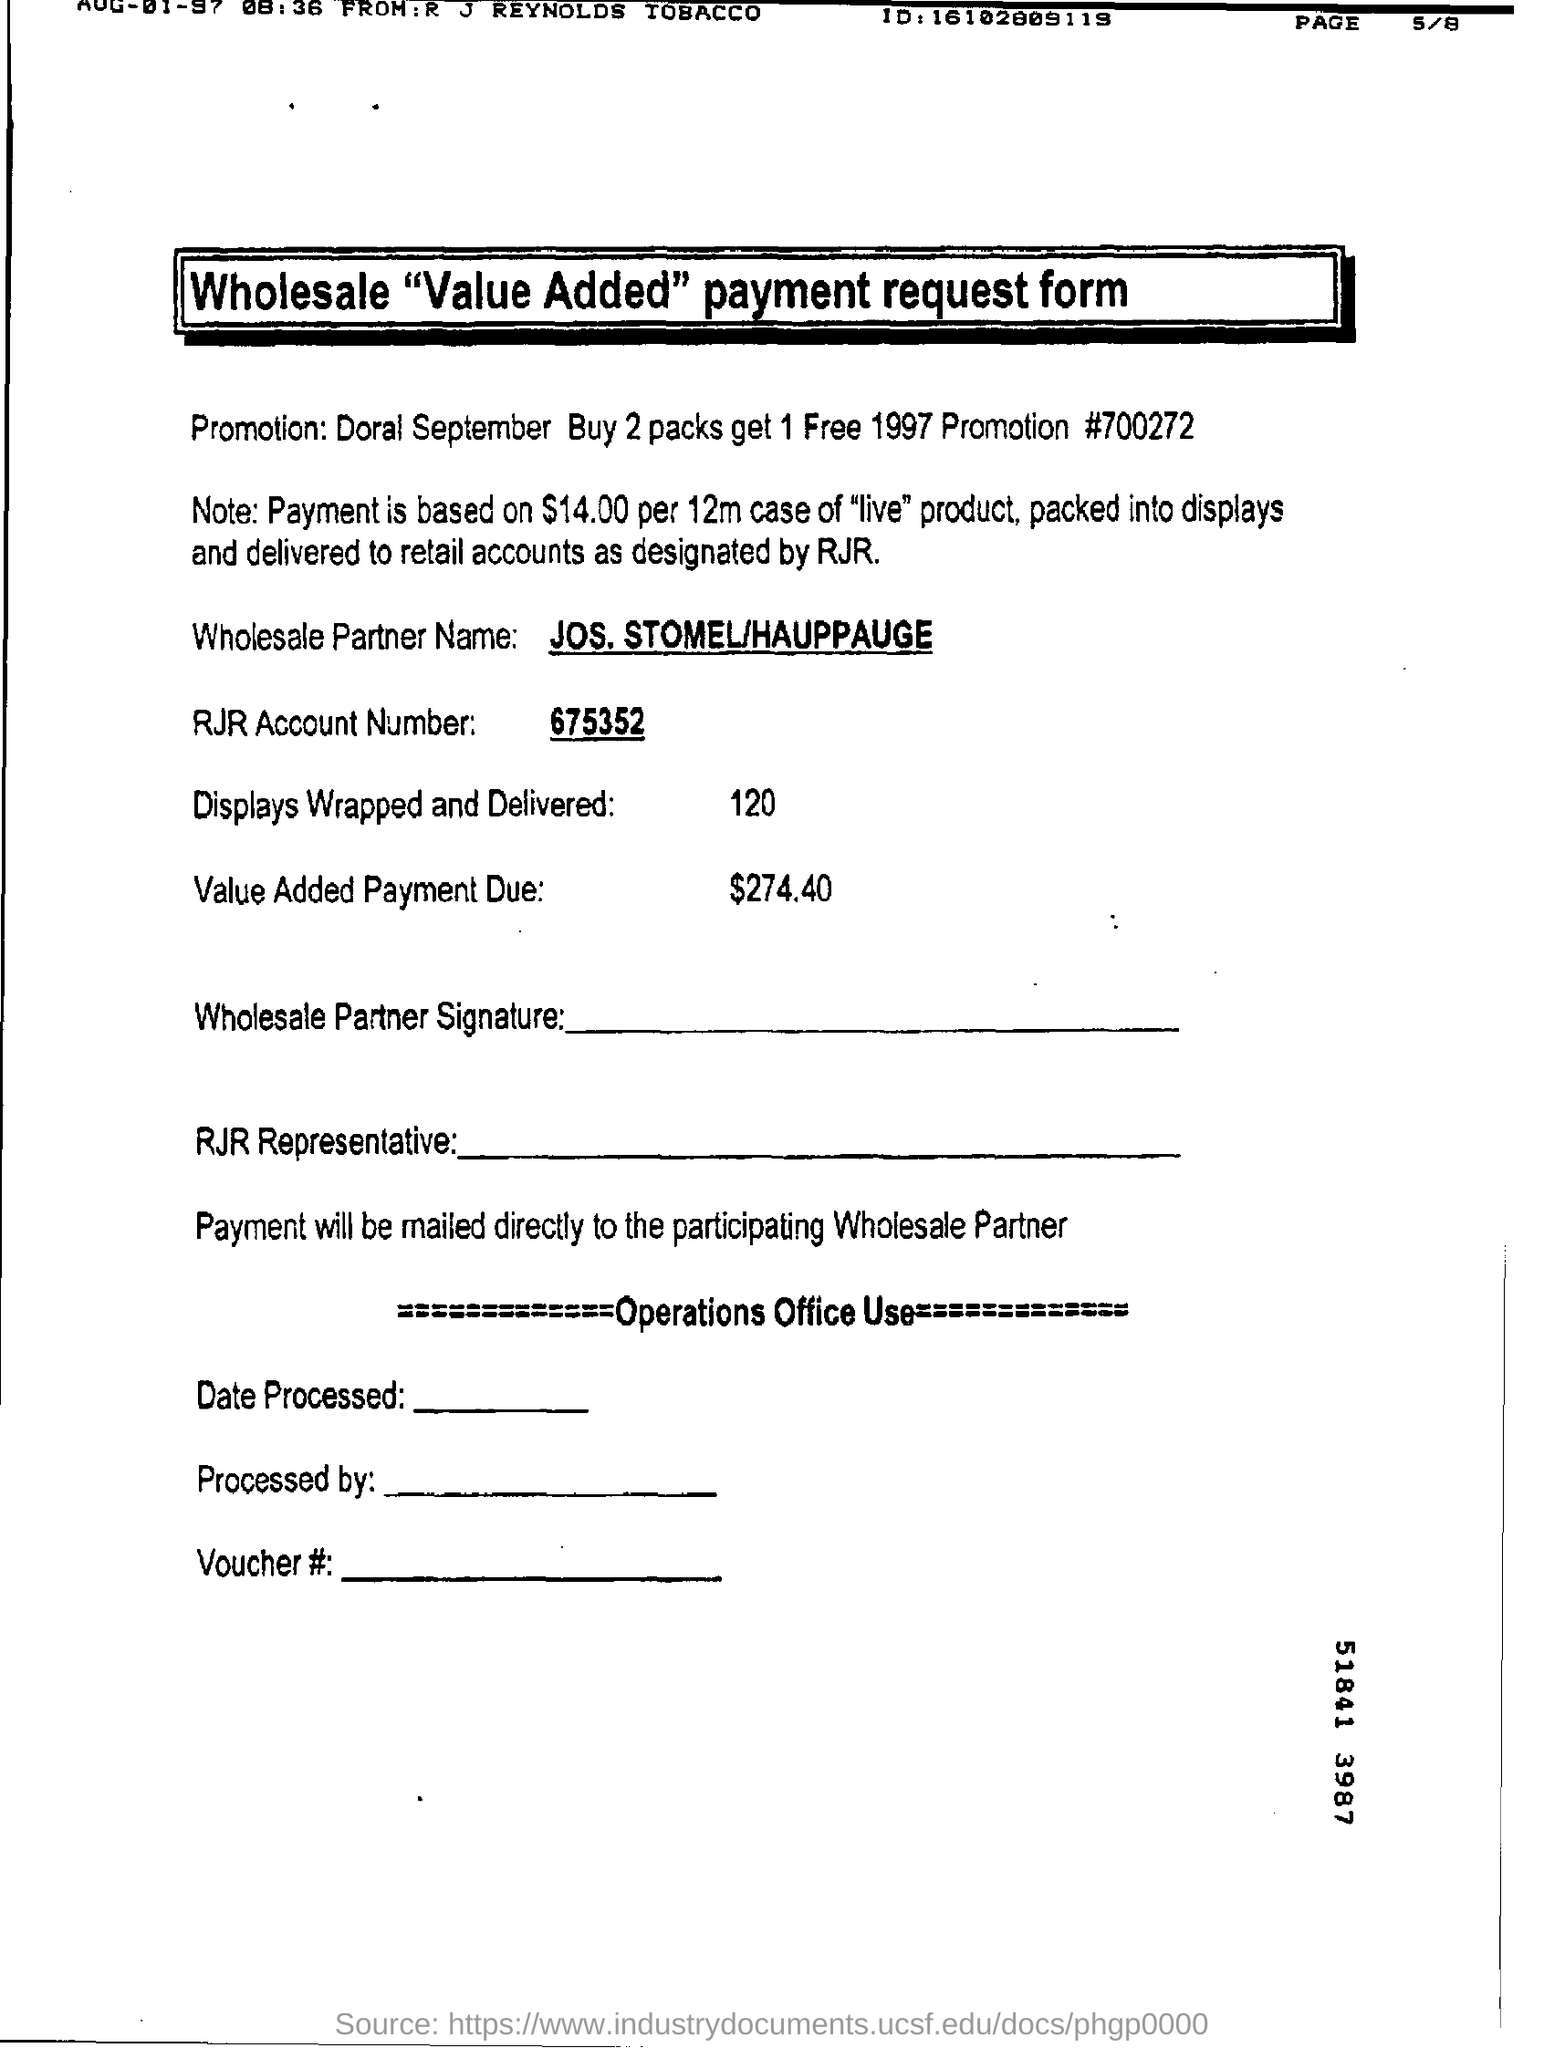What form is this as per the title?
Offer a terse response. Wholesale "value added" payment request form. What is the name of wholesale partner?
Provide a succinct answer. JOS.STOMEL/HAUPPAUGE. What is the RJR account number?
Ensure brevity in your answer.  675352. What is value added payment due?
Give a very brief answer. $274.40. How many displays were wrapped and delivered?
Provide a short and direct response. 120. 